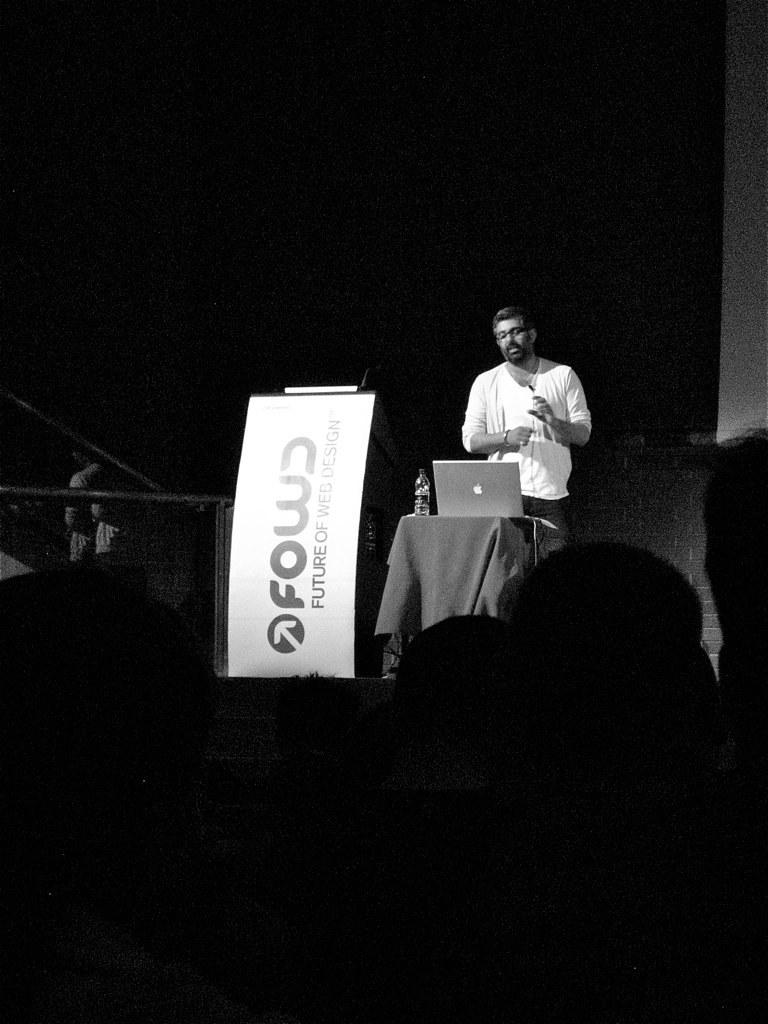What is the color scheme of the image? The image is black and white. What can be seen in the image besides the color scheme? There is a person standing in the image, as well as a laptop and a bottle on a table. What else is present in the image? There is a banner in the image. How many eggs are on the table in the image? There are no eggs present on the table in the image. What type of kettle can be seen in the image? There is no kettle present in the image. 